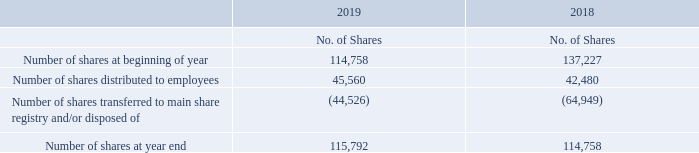16. SHARE-BASED PAYMENTS
a. Employee Share Plan
The Employee Share Plan (ESP) is available to all eligible employees each year to acquire ordinary shares in the Company from future remuneration (before tax). Shares to be issued or transferred under the ESP will be valued at the volume-weighted average price of the Company’s shares traded on the Australian Securities Exchange during the five business days immediately preceding the day the shares are issued or transferred. Shares issued under the ESP are not allowed to be sold, transferred or otherwise disposed until the earlier of the end of an initial three-year period, or the participant ceasing continuing employment with the Company.
Details of the movement in employee shares under the ESP are as follows:
The consideration for the shares issued on 22 May 2019 was $3.72 (7 May 2018: $4.24).
How much was the consideration for the shares issued on 22 May 2019? $3.72. How much was the consideration for the shares issued on 7 May 2018? $4.24. How many shares were distributed to employees in 2018? 42,480. What was the 2019 percentage change in number of shares distributed to employees?
Answer scale should be: percent. (45,560 - 42,480) / 42,480 
Answer: 7.25. What was the difference between the number of shares at the beginning and end of year 2019? 115,792 - 114,758 
Answer: 1034. What was the average number of shares at year end for both years? (115,792 + 114,758) / 2 
Answer: 115275. 